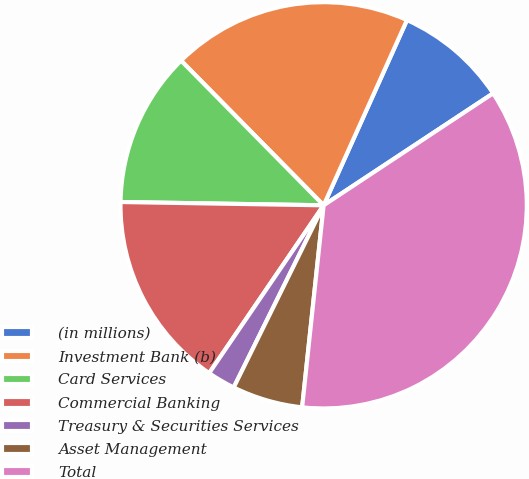Convert chart to OTSL. <chart><loc_0><loc_0><loc_500><loc_500><pie_chart><fcel>(in millions)<fcel>Investment Bank (b)<fcel>Card Services<fcel>Commercial Banking<fcel>Treasury & Securities Services<fcel>Asset Management<fcel>Total<nl><fcel>8.98%<fcel>19.11%<fcel>12.36%<fcel>15.73%<fcel>2.23%<fcel>5.61%<fcel>35.98%<nl></chart> 